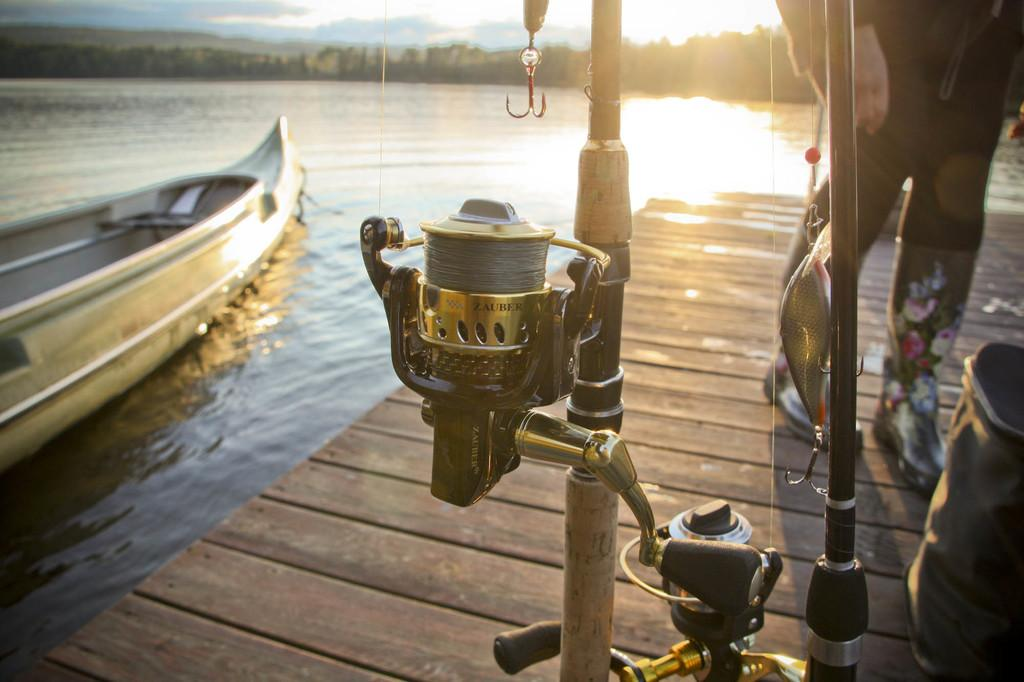What is located on the left side of the image? There is a boat on the left side of the image. Where is the boat situated? The boat is in the water. What can be seen on the right side of the image? There is a person on the right side of the image. What is the person doing in the image? The person is walking on a wooden floor. How many cows are swimming in the water next to the boat? There are no cows present in the image; it only features a boat in the water and a person walking on a wooden floor. What type of soup is being served in the channel? There is no soup or channel present in the image. 